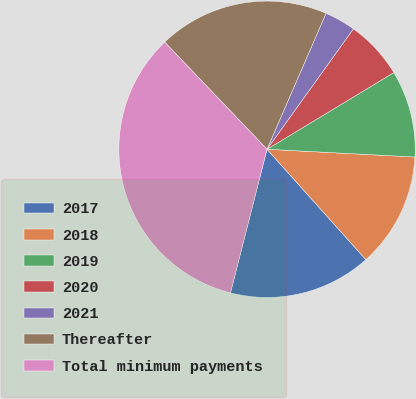<chart> <loc_0><loc_0><loc_500><loc_500><pie_chart><fcel>2017<fcel>2018<fcel>2019<fcel>2020<fcel>2021<fcel>Thereafter<fcel>Total minimum payments<nl><fcel>15.59%<fcel>12.54%<fcel>9.49%<fcel>6.44%<fcel>3.39%<fcel>18.65%<fcel>33.9%<nl></chart> 